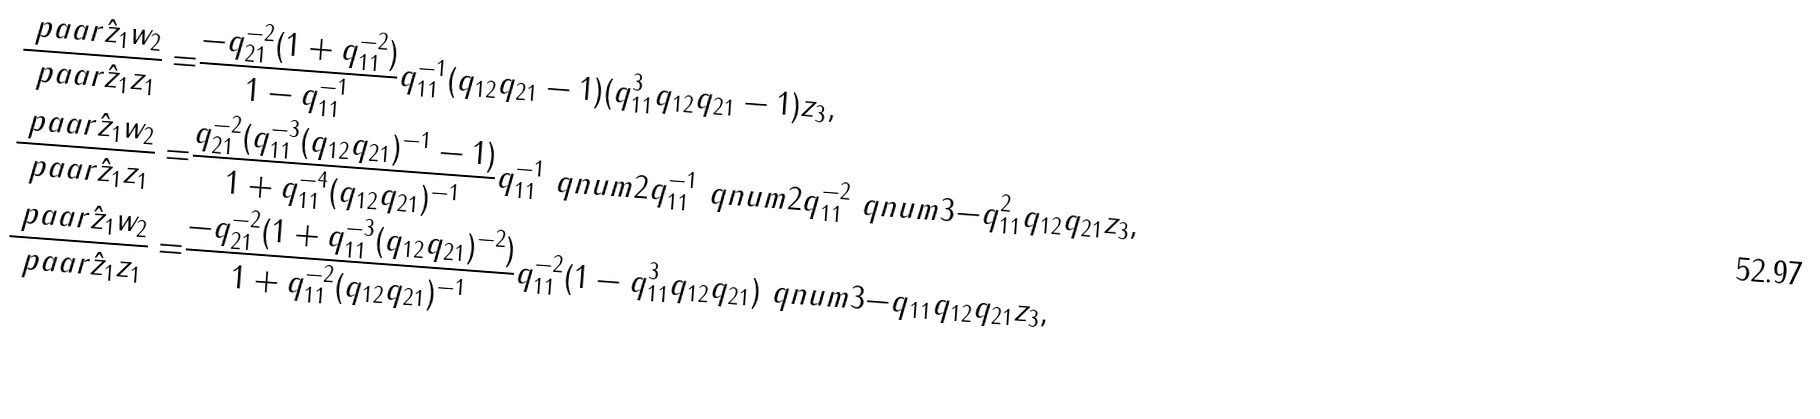<formula> <loc_0><loc_0><loc_500><loc_500>\frac { \ p a a r { \hat { z } _ { 1 } } { w _ { 2 } } } { \ p a a r { \hat { z } _ { 1 } } { z _ { 1 } } } = & \frac { - q _ { 2 1 } ^ { - 2 } ( 1 + q _ { 1 1 } ^ { - 2 } ) } { 1 - q _ { 1 1 } ^ { - 1 } } q _ { 1 1 } ^ { - 1 } ( q _ { 1 2 } q _ { 2 1 } - 1 ) ( q _ { 1 1 } ^ { 3 } q _ { 1 2 } q _ { 2 1 } - 1 ) z _ { 3 } , \\ \frac { \ p a a r { \hat { z } _ { 1 } } { w _ { 2 } } } { \ p a a r { \hat { z } _ { 1 } } { z _ { 1 } } } = & \frac { q _ { 2 1 } ^ { - 2 } ( q _ { 1 1 } ^ { - 3 } ( q _ { 1 2 } q _ { 2 1 } ) ^ { - 1 } - 1 ) } { 1 + q _ { 1 1 } ^ { - 4 } ( q _ { 1 2 } q _ { 2 1 } ) ^ { - 1 } } q _ { 1 1 } ^ { - 1 } \ q n u m { 2 } { q _ { 1 1 } ^ { - 1 } } \ q n u m { 2 } { q _ { 1 1 } ^ { - 2 } } \ q n u m { 3 } { - q _ { 1 1 } ^ { 2 } q _ { 1 2 } q _ { 2 1 } } z _ { 3 } , \\ \frac { \ p a a r { \hat { z } _ { 1 } } { w _ { 2 } } } { \ p a a r { \hat { z } _ { 1 } } { z _ { 1 } } } = & \frac { - q _ { 2 1 } ^ { - 2 } ( 1 + q _ { 1 1 } ^ { - 3 } ( q _ { 1 2 } q _ { 2 1 } ) ^ { - 2 } ) } { 1 + q _ { 1 1 } ^ { - 2 } ( q _ { 1 2 } q _ { 2 1 } ) ^ { - 1 } } q _ { 1 1 } ^ { - 2 } ( 1 - q _ { 1 1 } ^ { 3 } q _ { 1 2 } q _ { 2 1 } ) \ q n u m { 3 } { - q _ { 1 1 } q _ { 1 2 } q _ { 2 1 } } z _ { 3 } ,</formula> 